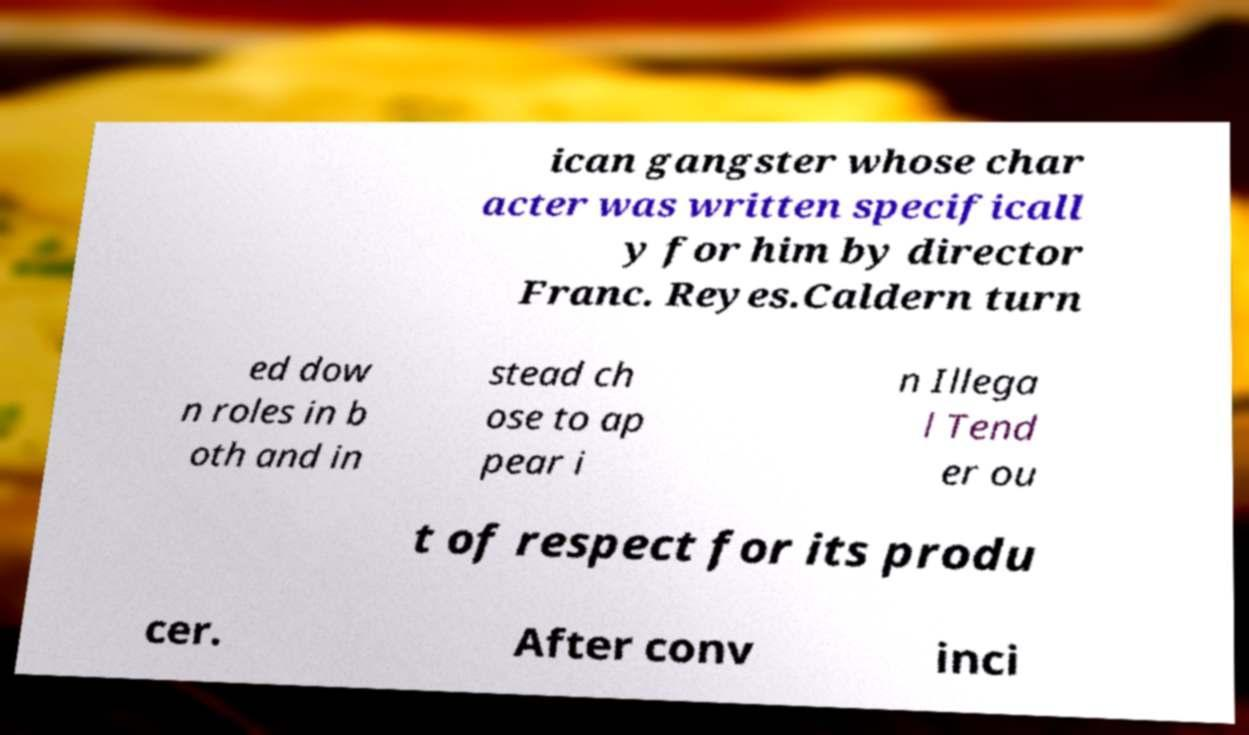Can you read and provide the text displayed in the image?This photo seems to have some interesting text. Can you extract and type it out for me? ican gangster whose char acter was written specificall y for him by director Franc. Reyes.Caldern turn ed dow n roles in b oth and in stead ch ose to ap pear i n Illega l Tend er ou t of respect for its produ cer. After conv inci 